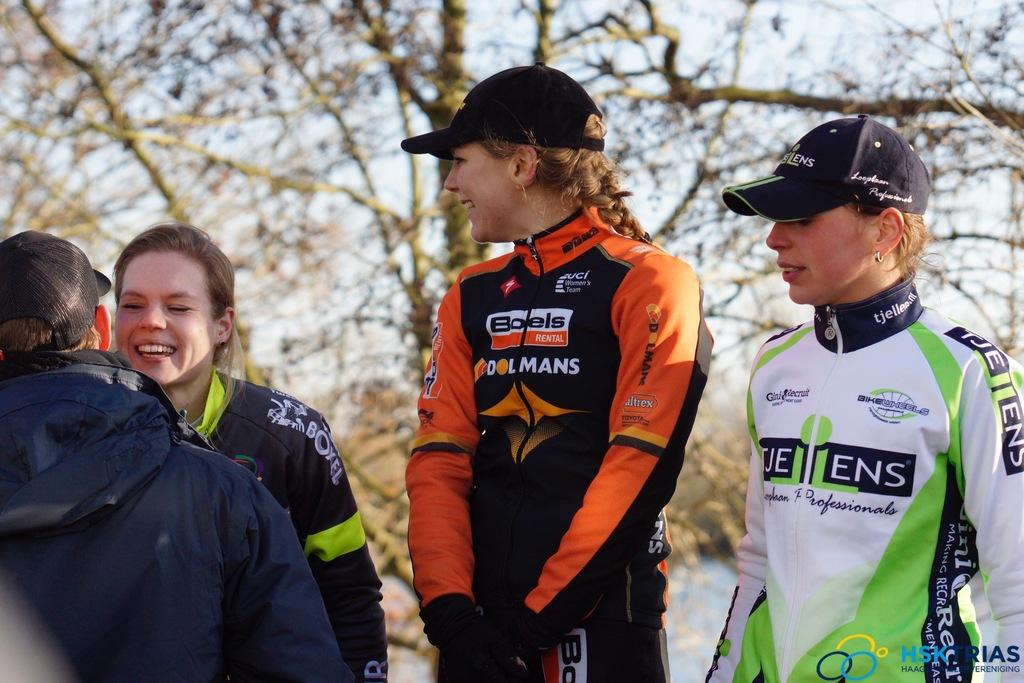<image>
Render a clear and concise summary of the photo. A woman in a Dolmans jacket watches on as a man greets the woman next to her. 